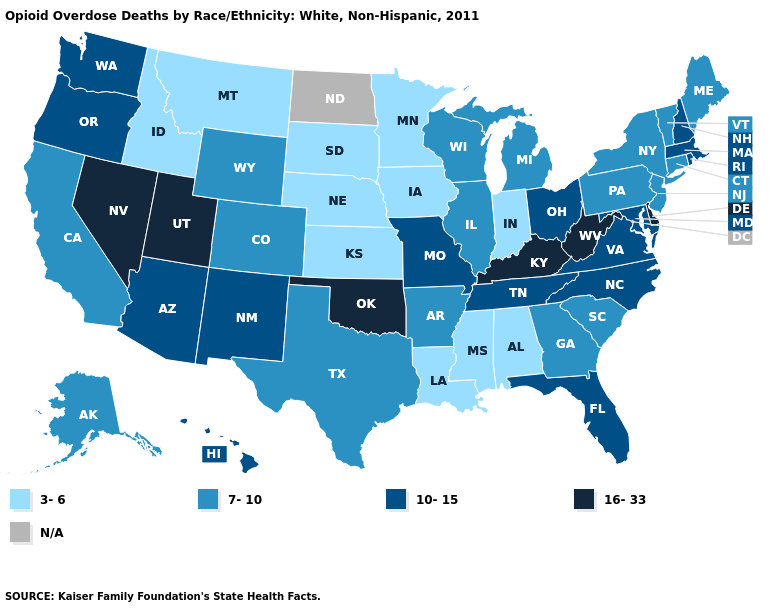Among the states that border Kansas , does Colorado have the highest value?
Quick response, please. No. Does New Jersey have the lowest value in the USA?
Quick response, please. No. What is the value of West Virginia?
Short answer required. 16-33. Name the states that have a value in the range 16-33?
Give a very brief answer. Delaware, Kentucky, Nevada, Oklahoma, Utah, West Virginia. Name the states that have a value in the range 10-15?
Answer briefly. Arizona, Florida, Hawaii, Maryland, Massachusetts, Missouri, New Hampshire, New Mexico, North Carolina, Ohio, Oregon, Rhode Island, Tennessee, Virginia, Washington. Name the states that have a value in the range N/A?
Answer briefly. North Dakota. Name the states that have a value in the range 16-33?
Quick response, please. Delaware, Kentucky, Nevada, Oklahoma, Utah, West Virginia. Is the legend a continuous bar?
Concise answer only. No. What is the lowest value in states that border Rhode Island?
Short answer required. 7-10. What is the highest value in the USA?
Answer briefly. 16-33. Does Mississippi have the lowest value in the USA?
Be succinct. Yes. Name the states that have a value in the range 16-33?
Be succinct. Delaware, Kentucky, Nevada, Oklahoma, Utah, West Virginia. What is the highest value in the MidWest ?
Keep it brief. 10-15. What is the highest value in the MidWest ?
Give a very brief answer. 10-15. 